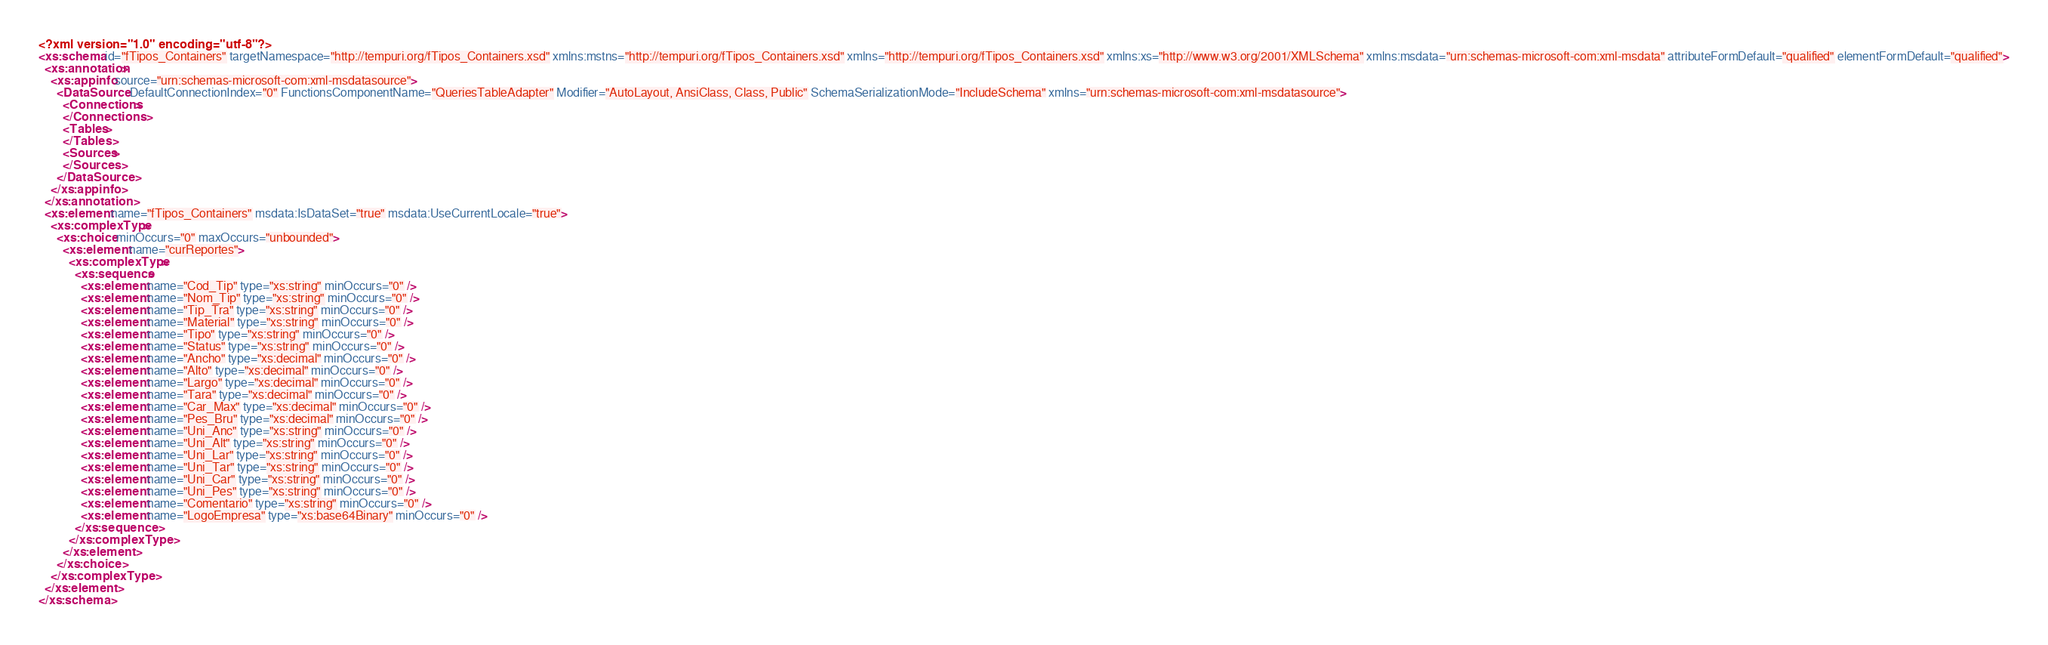<code> <loc_0><loc_0><loc_500><loc_500><_XML_><?xml version="1.0" encoding="utf-8"?>
<xs:schema id="fTipos_Containers" targetNamespace="http://tempuri.org/fTipos_Containers.xsd" xmlns:mstns="http://tempuri.org/fTipos_Containers.xsd" xmlns="http://tempuri.org/fTipos_Containers.xsd" xmlns:xs="http://www.w3.org/2001/XMLSchema" xmlns:msdata="urn:schemas-microsoft-com:xml-msdata" attributeFormDefault="qualified" elementFormDefault="qualified">
  <xs:annotation>
    <xs:appinfo source="urn:schemas-microsoft-com:xml-msdatasource">
      <DataSource DefaultConnectionIndex="0" FunctionsComponentName="QueriesTableAdapter" Modifier="AutoLayout, AnsiClass, Class, Public" SchemaSerializationMode="IncludeSchema" xmlns="urn:schemas-microsoft-com:xml-msdatasource">
        <Connections>
        </Connections>
        <Tables>
        </Tables>
        <Sources>
        </Sources>
      </DataSource>
    </xs:appinfo>
  </xs:annotation>
  <xs:element name="fTipos_Containers" msdata:IsDataSet="true" msdata:UseCurrentLocale="true">
    <xs:complexType>
      <xs:choice minOccurs="0" maxOccurs="unbounded">
        <xs:element name="curReportes">
          <xs:complexType>
            <xs:sequence>
              <xs:element name="Cod_Tip" type="xs:string" minOccurs="0" />
              <xs:element name="Nom_Tip" type="xs:string" minOccurs="0" />
              <xs:element name="Tip_Tra" type="xs:string" minOccurs="0" />
              <xs:element name="Material" type="xs:string" minOccurs="0" />
              <xs:element name="Tipo" type="xs:string" minOccurs="0" />
              <xs:element name="Status" type="xs:string" minOccurs="0" />
              <xs:element name="Ancho" type="xs:decimal" minOccurs="0" />
              <xs:element name="Alto" type="xs:decimal" minOccurs="0" />
              <xs:element name="Largo" type="xs:decimal" minOccurs="0" />
              <xs:element name="Tara" type="xs:decimal" minOccurs="0" />
              <xs:element name="Car_Max" type="xs:decimal" minOccurs="0" />
              <xs:element name="Pes_Bru" type="xs:decimal" minOccurs="0" />
              <xs:element name="Uni_Anc" type="xs:string" minOccurs="0" />
              <xs:element name="Uni_Alt" type="xs:string" minOccurs="0" />
              <xs:element name="Uni_Lar" type="xs:string" minOccurs="0" />
              <xs:element name="Uni_Tar" type="xs:string" minOccurs="0" />
              <xs:element name="Uni_Car" type="xs:string" minOccurs="0" />
              <xs:element name="Uni_Pes" type="xs:string" minOccurs="0" />
              <xs:element name="Comentario" type="xs:string" minOccurs="0" />
              <xs:element name="LogoEmpresa" type="xs:base64Binary" minOccurs="0" />
            </xs:sequence>
          </xs:complexType>
        </xs:element>
      </xs:choice>
    </xs:complexType>
  </xs:element>
</xs:schema></code> 